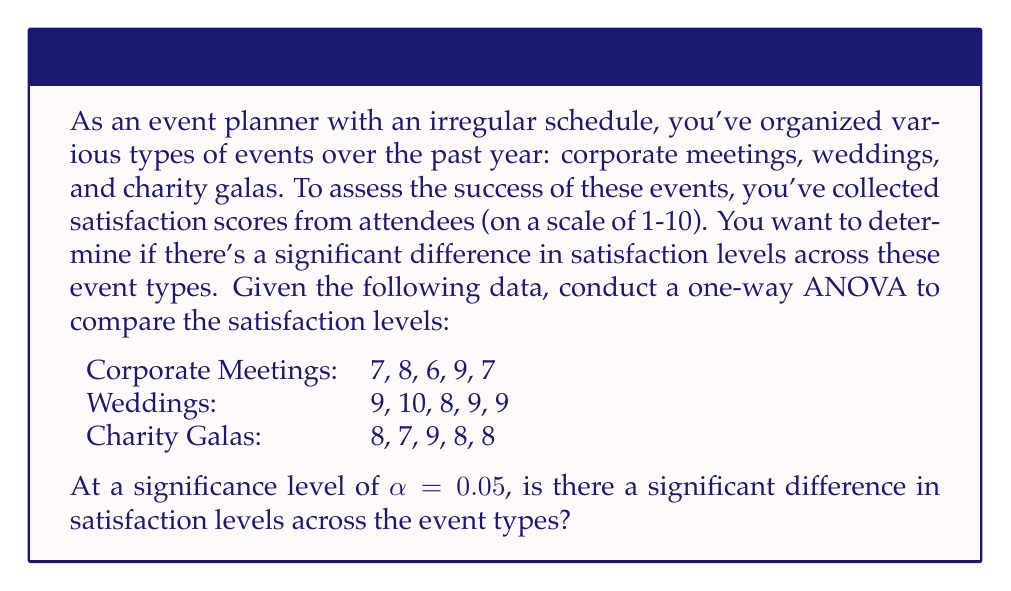Can you answer this question? To conduct a one-way ANOVA, we'll follow these steps:

1. Calculate the sum of squares between groups (SSB) and within groups (SSW).
2. Calculate the degrees of freedom for between groups (dfB) and within groups (dfW).
3. Calculate the mean square between groups (MSB) and within groups (MSW).
4. Calculate the F-statistic.
5. Compare the F-statistic to the critical F-value.

Step 1: Calculate SSB and SSW

First, we need to calculate the grand mean:
$$\bar{X} = \frac{7+8+6+9+7+9+10+8+9+9+8+7+9+8+8}{15} = 8.13$$

Now, calculate the sum of squares between groups (SSB):
$$SSB = 5[(7.4-8.13)^2 + (9-8.13)^2 + (8-8.13)^2] = 7.23$$

For SSW, calculate the sum of squared deviations within each group:
Corporate Meetings: $\sum(X-\bar{X})^2 = 4.8$
Weddings: $\sum(X-\bar{X})^2 = 2$
Charity Galas: $\sum(X-\bar{X})^2 = 2$

$$SSW = 4.8 + 2 + 2 = 8.8$$

Step 2: Calculate degrees of freedom

$$df_B = k - 1 = 3 - 1 = 2$$
$$df_W = N - k = 15 - 3 = 12$$

Where k is the number of groups and N is the total sample size.

Step 3: Calculate mean squares

$$MSB = \frac{SSB}{df_B} = \frac{7.23}{2} = 3.615$$
$$MSW = \frac{SSW}{df_W} = \frac{8.8}{12} = 0.733$$

Step 4: Calculate F-statistic

$$F = \frac{MSB}{MSW} = \frac{3.615}{0.733} = 4.93$$

Step 5: Compare F-statistic to critical F-value

At $\alpha = 0.05$, with $df_B = 2$ and $df_W = 12$, the critical F-value is approximately 3.89.

Since our calculated F-statistic (4.93) is greater than the critical F-value (3.89), we reject the null hypothesis.
Answer: Yes, there is a significant difference in satisfaction levels across the event types at the 0.05 significance level. The F-statistic (4.93) exceeds the critical F-value (3.89), indicating that the variation between groups is significantly larger than the variation within groups. 